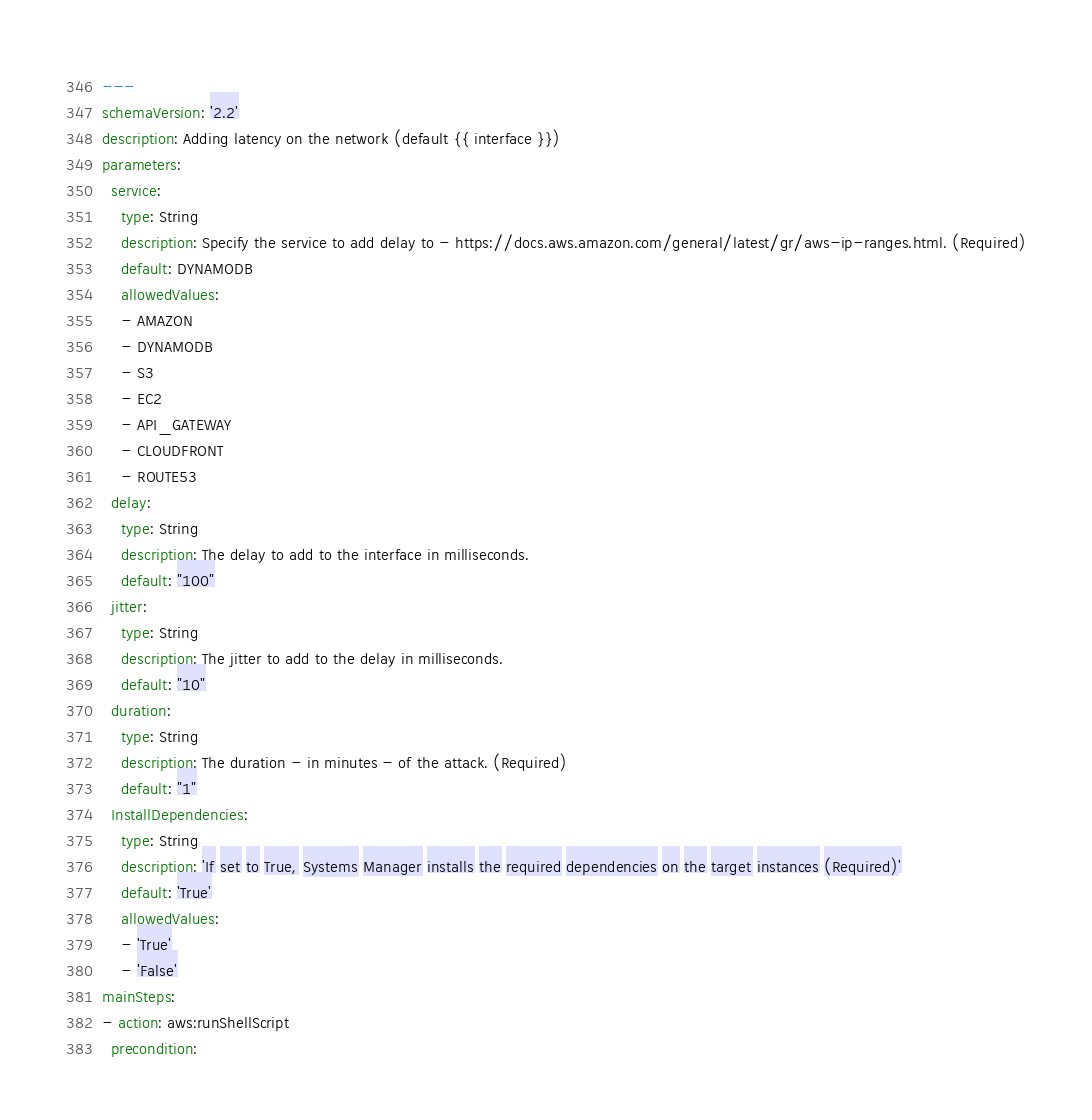Convert code to text. <code><loc_0><loc_0><loc_500><loc_500><_YAML_>---
schemaVersion: '2.2'
description: Adding latency on the network (default {{ interface }})
parameters:
  service:
    type: String
    description: Specify the service to add delay to - https://docs.aws.amazon.com/general/latest/gr/aws-ip-ranges.html. (Required)
    default: DYNAMODB
    allowedValues:
    - AMAZON
    - DYNAMODB
    - S3
    - EC2
    - API_GATEWAY
    - CLOUDFRONT
    - ROUTE53
  delay:
    type: String
    description: The delay to add to the interface in milliseconds.
    default: "100"
  jitter:
    type: String
    description: The jitter to add to the delay in milliseconds.
    default: "10"
  duration:
    type: String
    description: The duration - in minutes - of the attack. (Required)
    default: "1"
  InstallDependencies:
    type: String
    description: 'If set to True, Systems Manager installs the required dependencies on the target instances (Required)'
    default: 'True'
    allowedValues:
    - 'True'
    - 'False'
mainSteps:
- action: aws:runShellScript
  precondition:</code> 